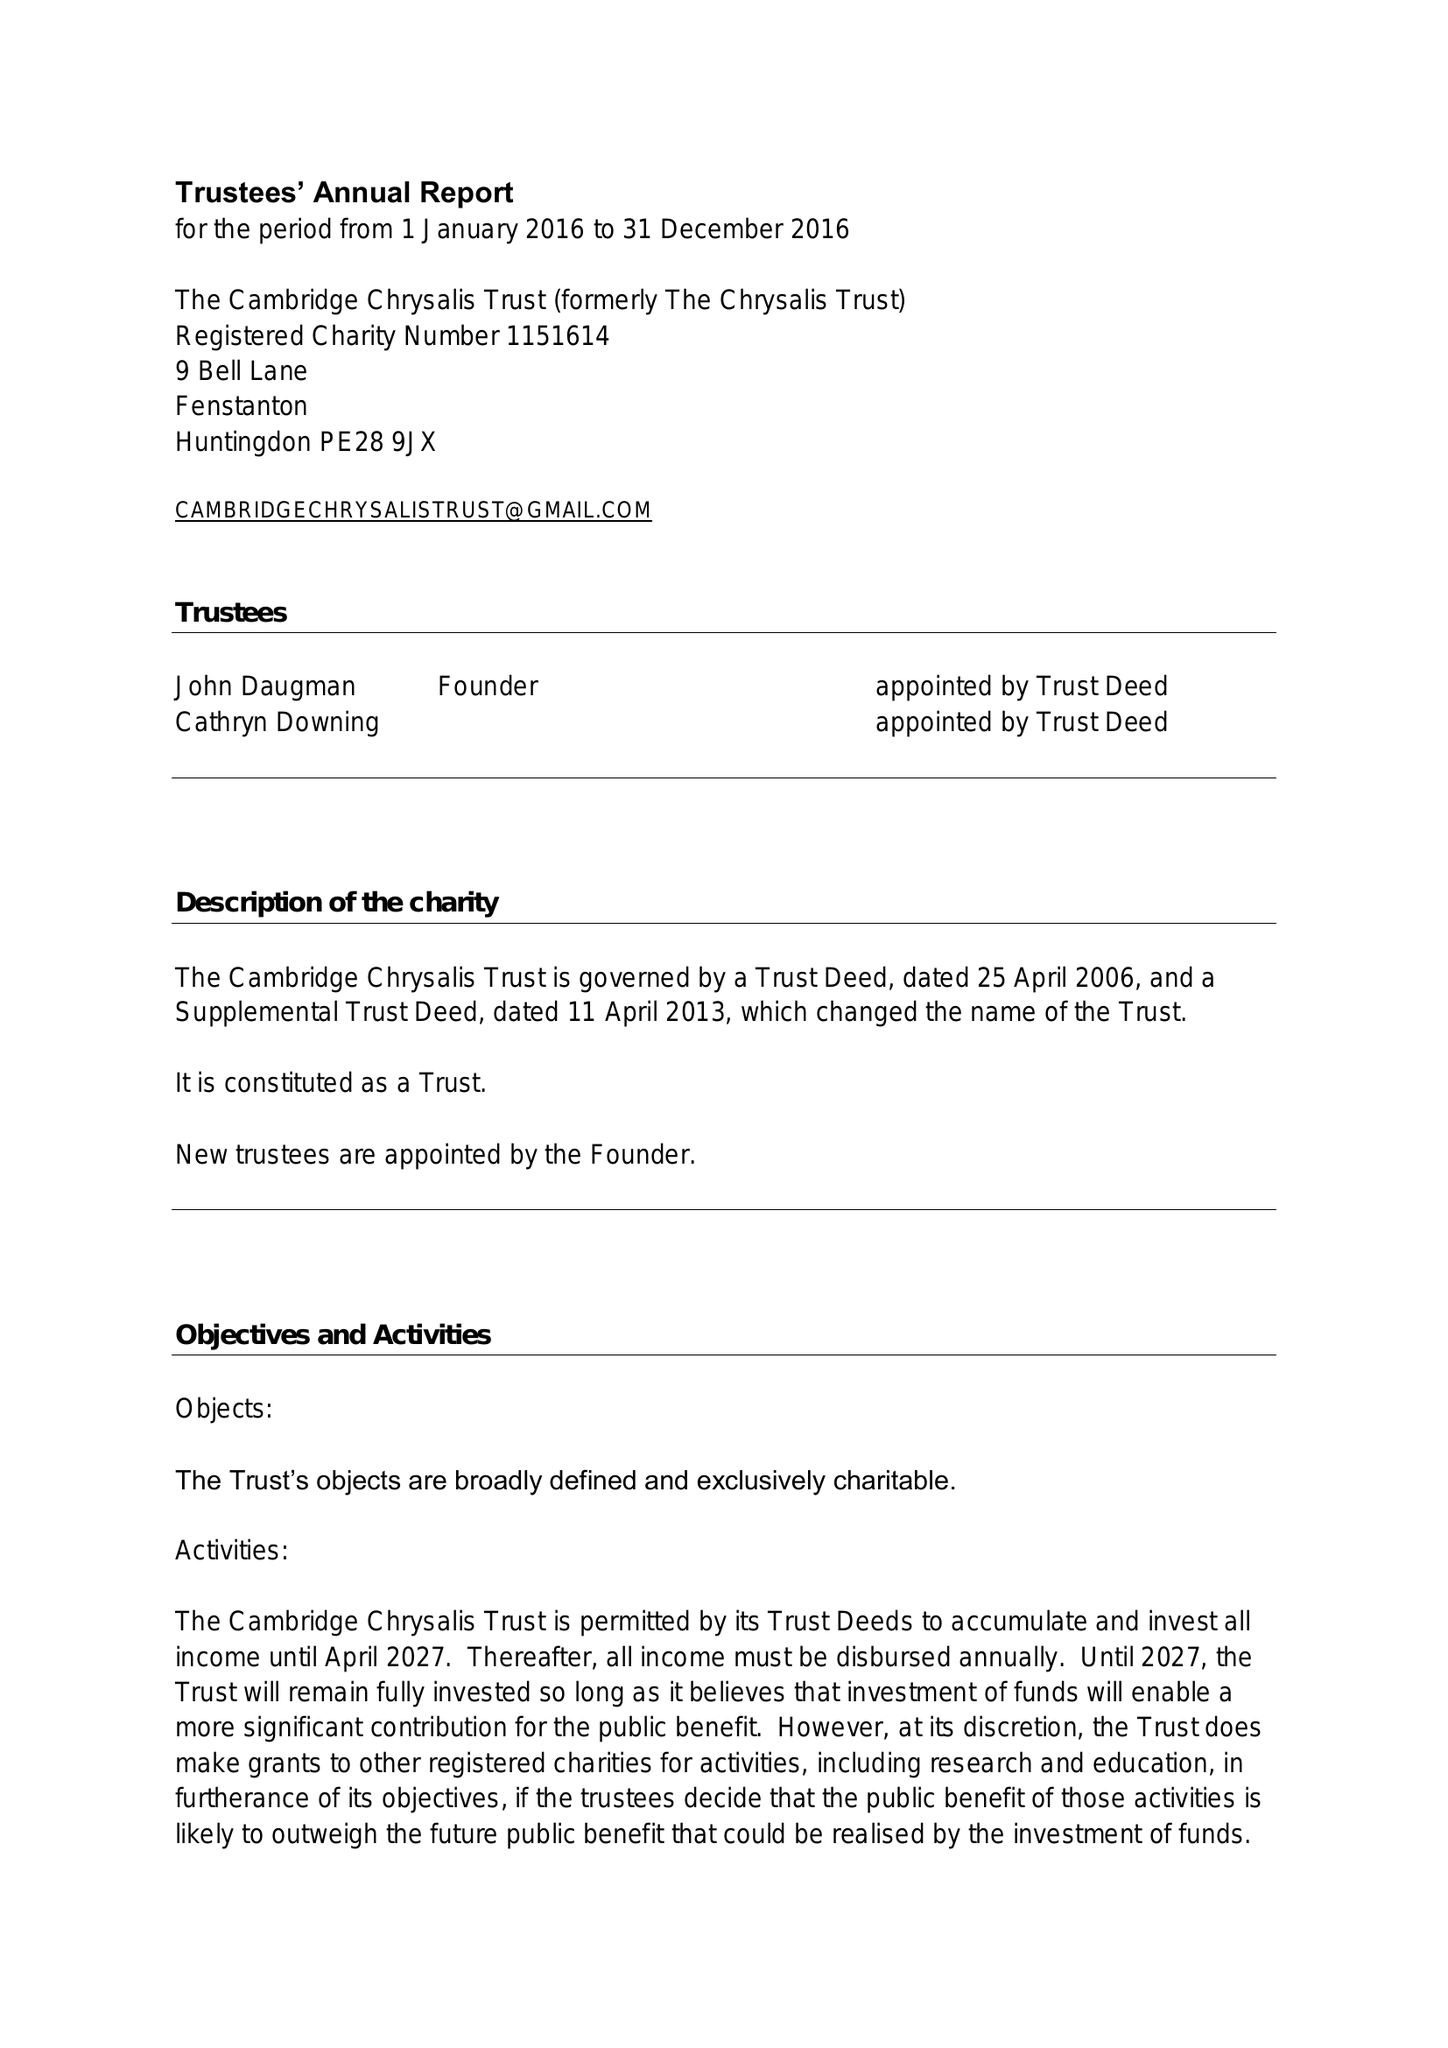What is the value for the spending_annually_in_british_pounds?
Answer the question using a single word or phrase. 10200.00 